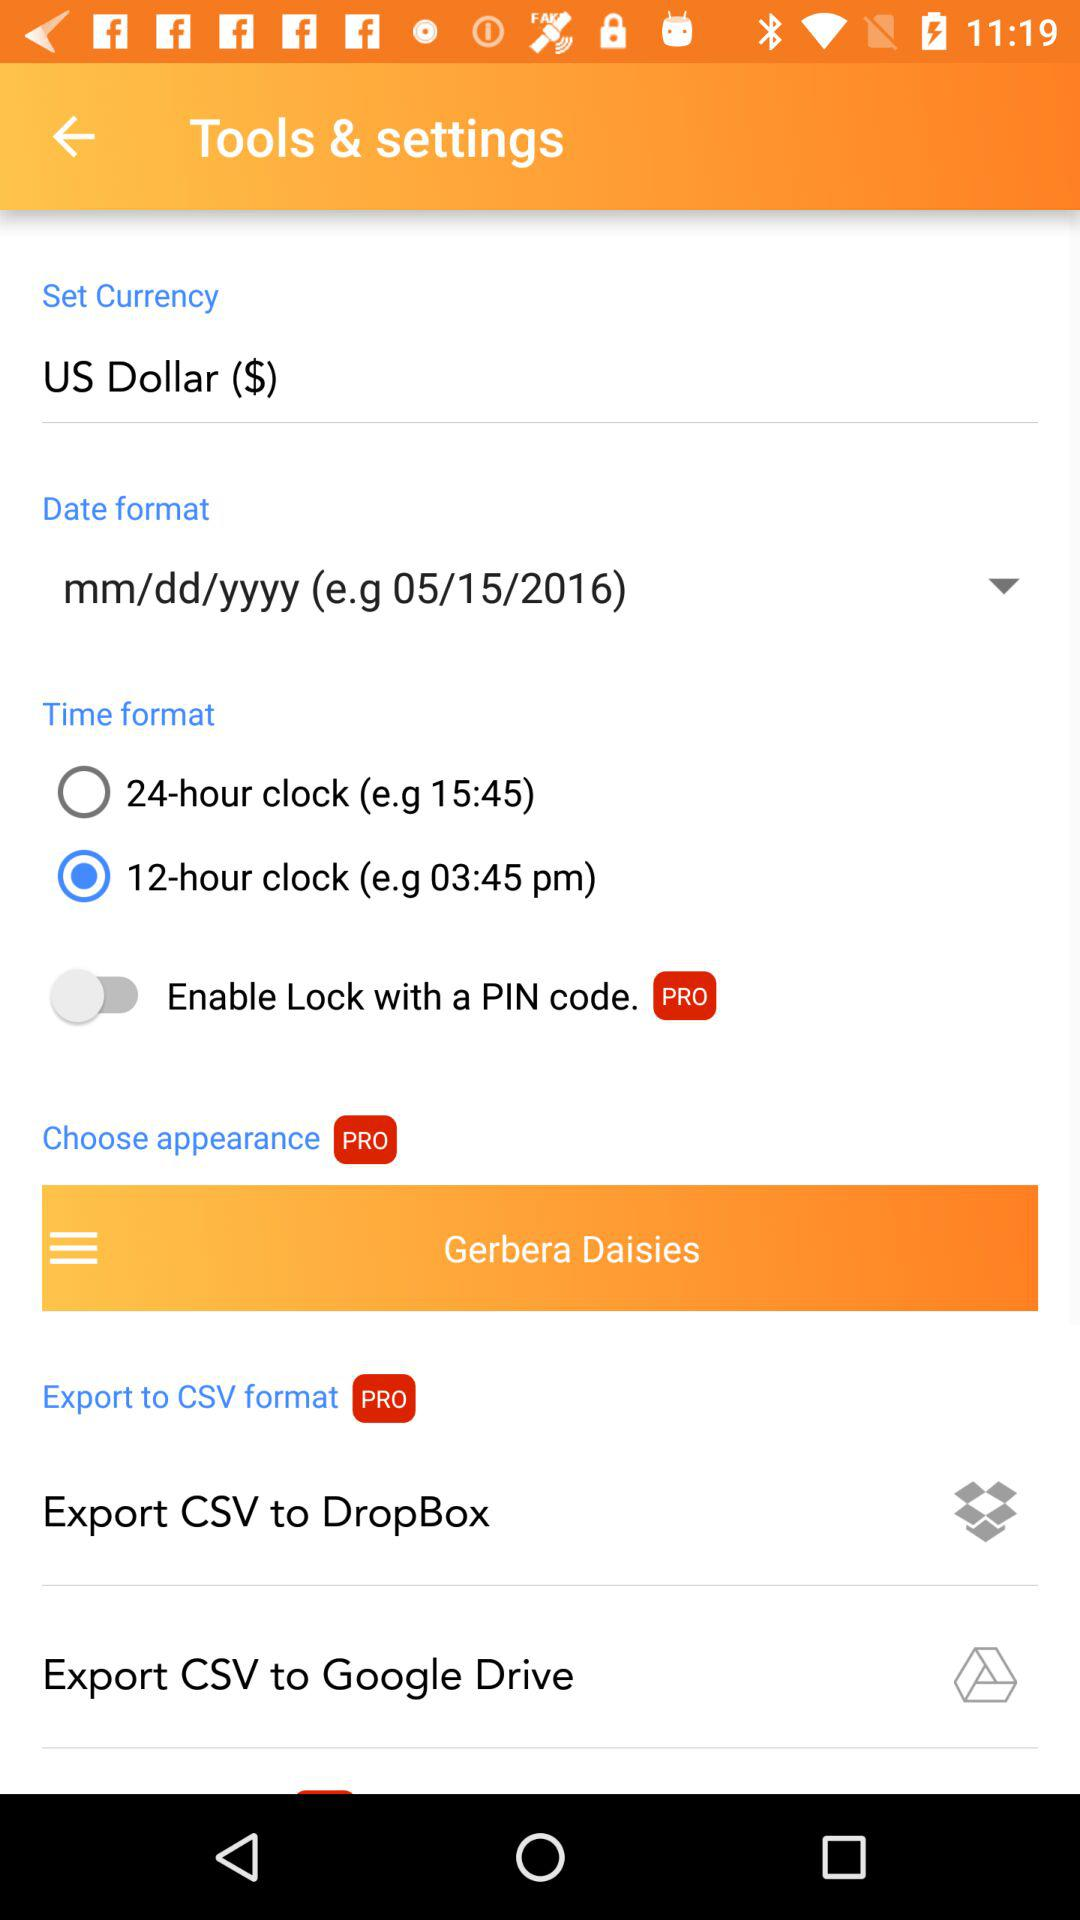Which currency is selected? The selected currency is the US dollar. 